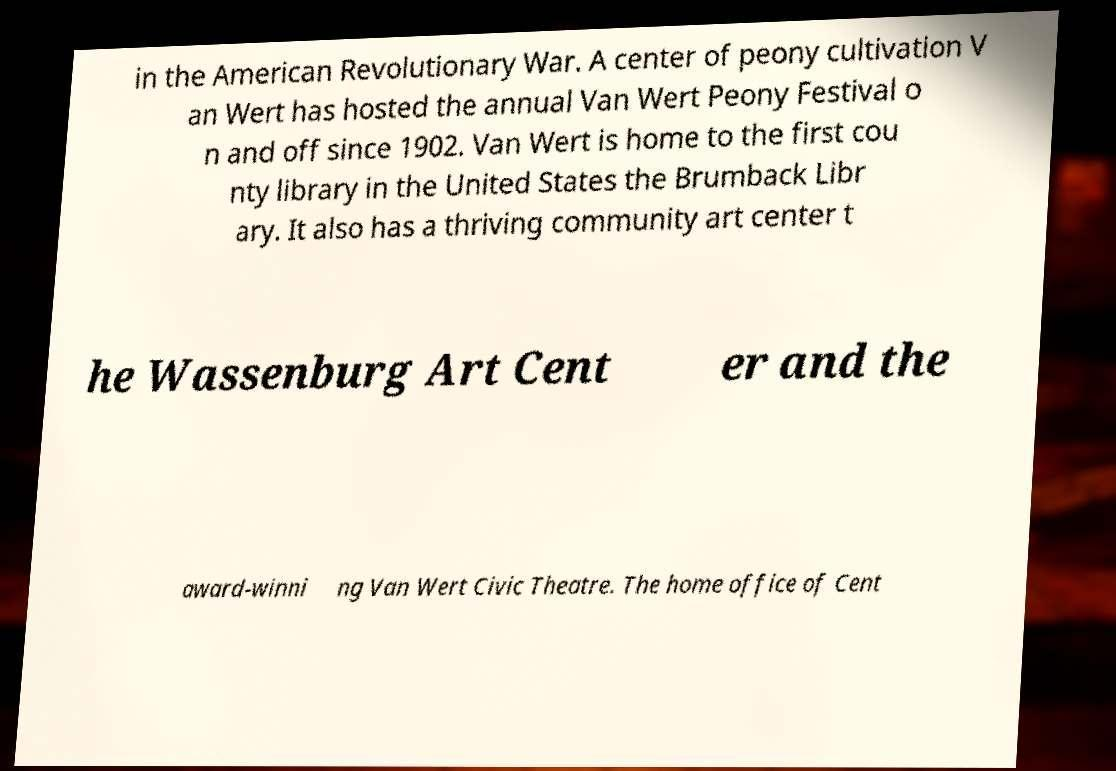There's text embedded in this image that I need extracted. Can you transcribe it verbatim? in the American Revolutionary War. A center of peony cultivation V an Wert has hosted the annual Van Wert Peony Festival o n and off since 1902. Van Wert is home to the first cou nty library in the United States the Brumback Libr ary. It also has a thriving community art center t he Wassenburg Art Cent er and the award-winni ng Van Wert Civic Theatre. The home office of Cent 